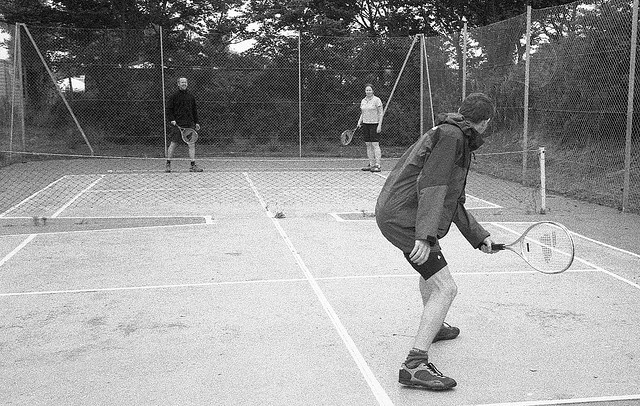Describe the objects in this image and their specific colors. I can see people in gray, black, darkgray, and lightgray tones, tennis racket in gray, lightgray, darkgray, and black tones, people in gray, black, darkgray, and lightgray tones, people in gray, darkgray, lightgray, and black tones, and tennis racket in gray, black, and lightgray tones in this image. 